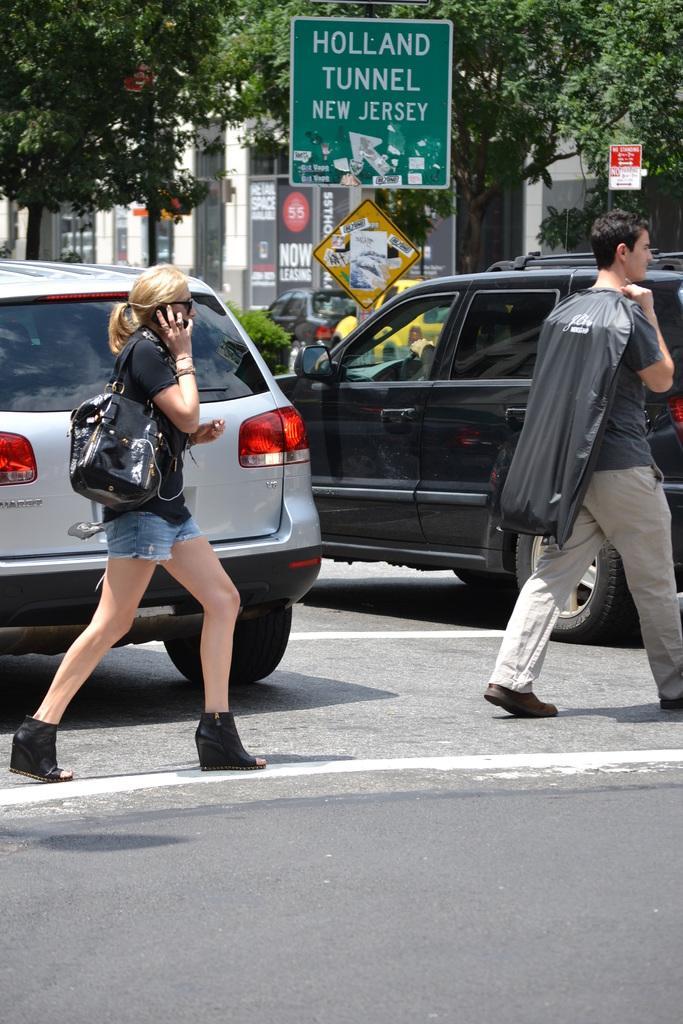In one or two sentences, can you explain what this image depicts? In the image in the center we can see two persons were walking on the road and they were holding some objects. In the background we can see trees,banners,sign boards,building,wall and few vehicles. 